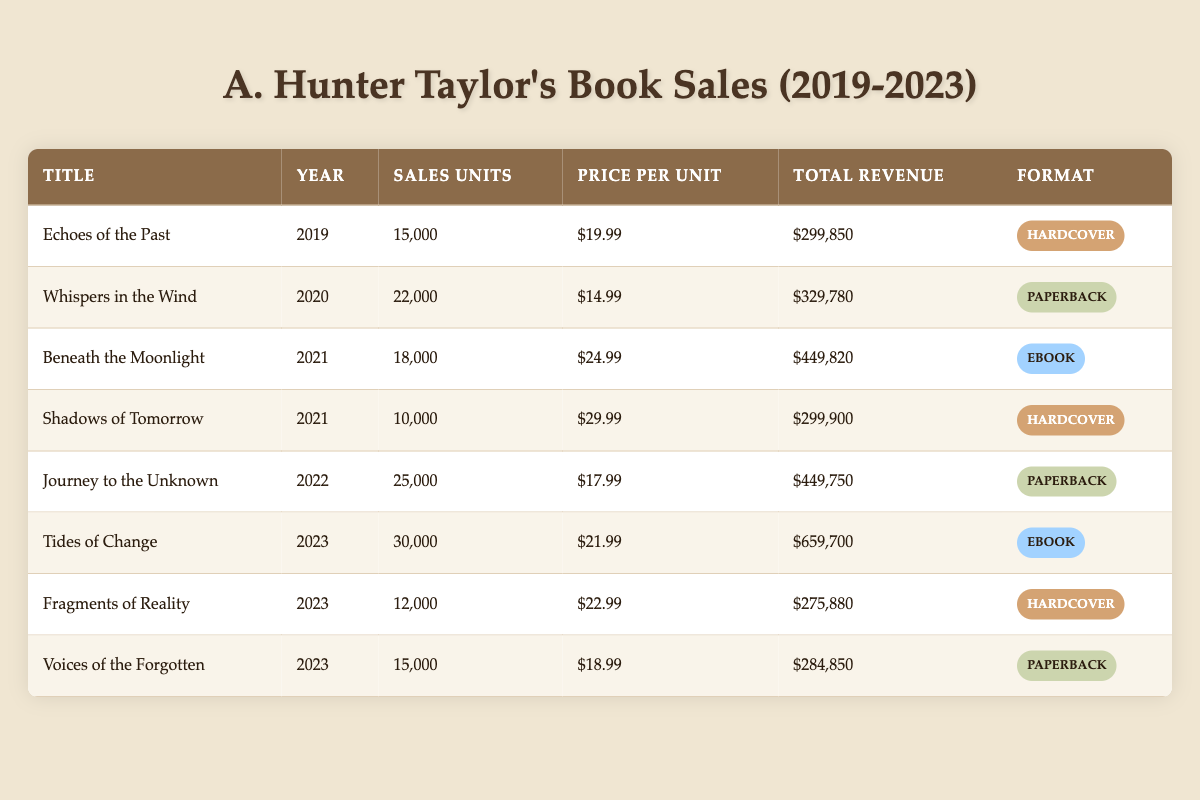What was the total revenue generated from "Tides of Change"? The total revenue is listed directly in the table under the column "Total Revenue" for the title "Tides of Change", which shows $659,700.
Answer: $659,700 Which book had the highest number of sales units in 2021? In 2021, the table lists "Beneath the Moonlight" with 18,000 sales units and "Shadows of Tomorrow" with 10,000 sales units. Therefore, "Beneath the Moonlight" had the highest.
Answer: Beneath the Moonlight How many total sales units were sold across all books in 2023? Summing the sales units from each title in 2023: Tides of Change (30,000) + Fragments of Reality (12,000) + Voices of the Forgotten (15,000) = 30,000 + 12,000 + 15,000 = 57,000.
Answer: 57,000 Is "Whispers in the Wind" a hardcover book? The format for "Whispers in the Wind" is listed as "Paperback" in the table, indicating that it is not a hardcover.
Answer: No What was the average price per unit of all books released in 2020 and 2021? The books released in 2020 are "Whispers in the Wind" priced at $14.99 and in 2021, "Beneath the Moonlight" at $24.99 and "Shadows of Tomorrow" at $29.99. The average price is calculated by summing these prices: (14.99 + 24.99 + 29.99) = 69.97, then dividing by the number of books (3) gives an average price of approximately 23.32.
Answer: $23.32 Which format of book had the highest total revenue in 2022? The only book listed in 2022 is "Journey to the Unknown" with a total revenue of $449,750, which confirms that this is the highest total revenue for that year since it is the only entry.
Answer: Hardcover 